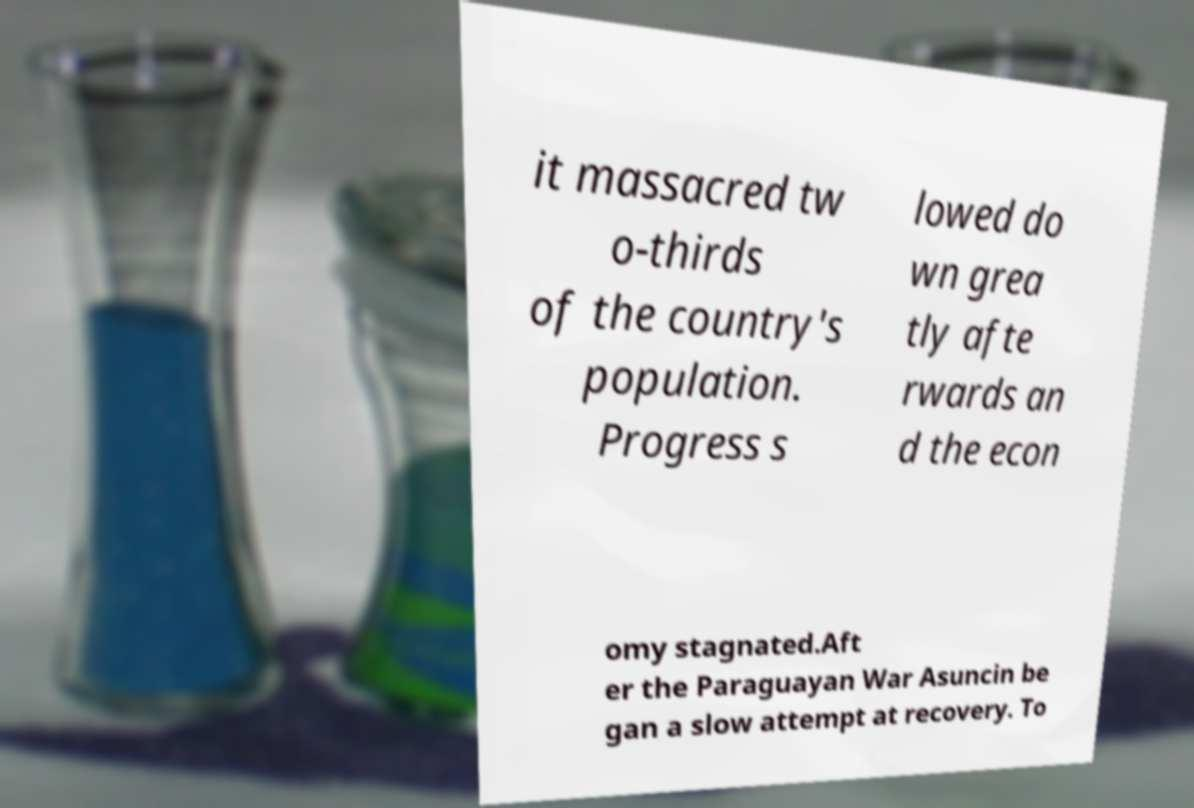What messages or text are displayed in this image? I need them in a readable, typed format. it massacred tw o-thirds of the country's population. Progress s lowed do wn grea tly afte rwards an d the econ omy stagnated.Aft er the Paraguayan War Asuncin be gan a slow attempt at recovery. To 